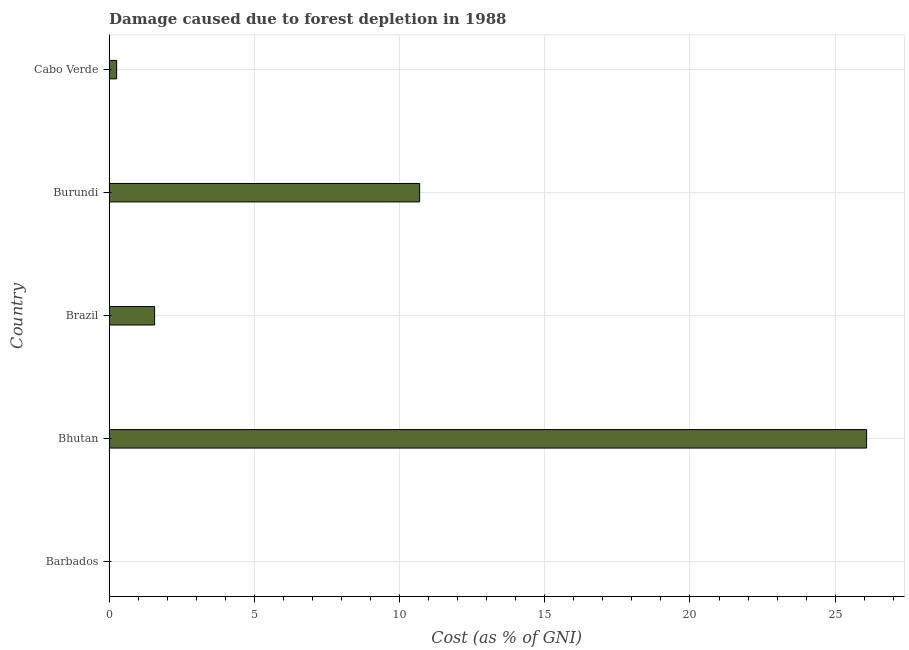What is the title of the graph?
Keep it short and to the point. Damage caused due to forest depletion in 1988. What is the label or title of the X-axis?
Offer a terse response. Cost (as % of GNI). What is the damage caused due to forest depletion in Bhutan?
Your answer should be compact. 26.08. Across all countries, what is the maximum damage caused due to forest depletion?
Offer a terse response. 26.08. Across all countries, what is the minimum damage caused due to forest depletion?
Your answer should be compact. 0.01. In which country was the damage caused due to forest depletion maximum?
Ensure brevity in your answer.  Bhutan. In which country was the damage caused due to forest depletion minimum?
Offer a very short reply. Barbados. What is the sum of the damage caused due to forest depletion?
Ensure brevity in your answer.  38.62. What is the difference between the damage caused due to forest depletion in Brazil and Cabo Verde?
Keep it short and to the point. 1.31. What is the average damage caused due to forest depletion per country?
Your response must be concise. 7.72. What is the median damage caused due to forest depletion?
Give a very brief answer. 1.57. What is the ratio of the damage caused due to forest depletion in Burundi to that in Cabo Verde?
Your response must be concise. 41.09. What is the difference between the highest and the second highest damage caused due to forest depletion?
Make the answer very short. 15.39. What is the difference between the highest and the lowest damage caused due to forest depletion?
Make the answer very short. 26.07. In how many countries, is the damage caused due to forest depletion greater than the average damage caused due to forest depletion taken over all countries?
Provide a succinct answer. 2. Are all the bars in the graph horizontal?
Ensure brevity in your answer.  Yes. How many countries are there in the graph?
Keep it short and to the point. 5. What is the Cost (as % of GNI) in Barbados?
Keep it short and to the point. 0.01. What is the Cost (as % of GNI) of Bhutan?
Ensure brevity in your answer.  26.08. What is the Cost (as % of GNI) in Brazil?
Your answer should be very brief. 1.57. What is the Cost (as % of GNI) of Burundi?
Keep it short and to the point. 10.69. What is the Cost (as % of GNI) in Cabo Verde?
Ensure brevity in your answer.  0.26. What is the difference between the Cost (as % of GNI) in Barbados and Bhutan?
Your answer should be very brief. -26.07. What is the difference between the Cost (as % of GNI) in Barbados and Brazil?
Ensure brevity in your answer.  -1.56. What is the difference between the Cost (as % of GNI) in Barbados and Burundi?
Give a very brief answer. -10.68. What is the difference between the Cost (as % of GNI) in Barbados and Cabo Verde?
Offer a terse response. -0.25. What is the difference between the Cost (as % of GNI) in Bhutan and Brazil?
Provide a short and direct response. 24.51. What is the difference between the Cost (as % of GNI) in Bhutan and Burundi?
Ensure brevity in your answer.  15.39. What is the difference between the Cost (as % of GNI) in Bhutan and Cabo Verde?
Offer a very short reply. 25.82. What is the difference between the Cost (as % of GNI) in Brazil and Burundi?
Your response must be concise. -9.12. What is the difference between the Cost (as % of GNI) in Brazil and Cabo Verde?
Your answer should be compact. 1.31. What is the difference between the Cost (as % of GNI) in Burundi and Cabo Verde?
Provide a succinct answer. 10.43. What is the ratio of the Cost (as % of GNI) in Barbados to that in Bhutan?
Offer a terse response. 0. What is the ratio of the Cost (as % of GNI) in Barbados to that in Brazil?
Your answer should be compact. 0.01. What is the ratio of the Cost (as % of GNI) in Barbados to that in Cabo Verde?
Your response must be concise. 0.05. What is the ratio of the Cost (as % of GNI) in Bhutan to that in Brazil?
Provide a short and direct response. 16.63. What is the ratio of the Cost (as % of GNI) in Bhutan to that in Burundi?
Keep it short and to the point. 2.44. What is the ratio of the Cost (as % of GNI) in Bhutan to that in Cabo Verde?
Offer a very short reply. 100.23. What is the ratio of the Cost (as % of GNI) in Brazil to that in Burundi?
Your response must be concise. 0.15. What is the ratio of the Cost (as % of GNI) in Brazil to that in Cabo Verde?
Offer a very short reply. 6.03. What is the ratio of the Cost (as % of GNI) in Burundi to that in Cabo Verde?
Provide a succinct answer. 41.09. 